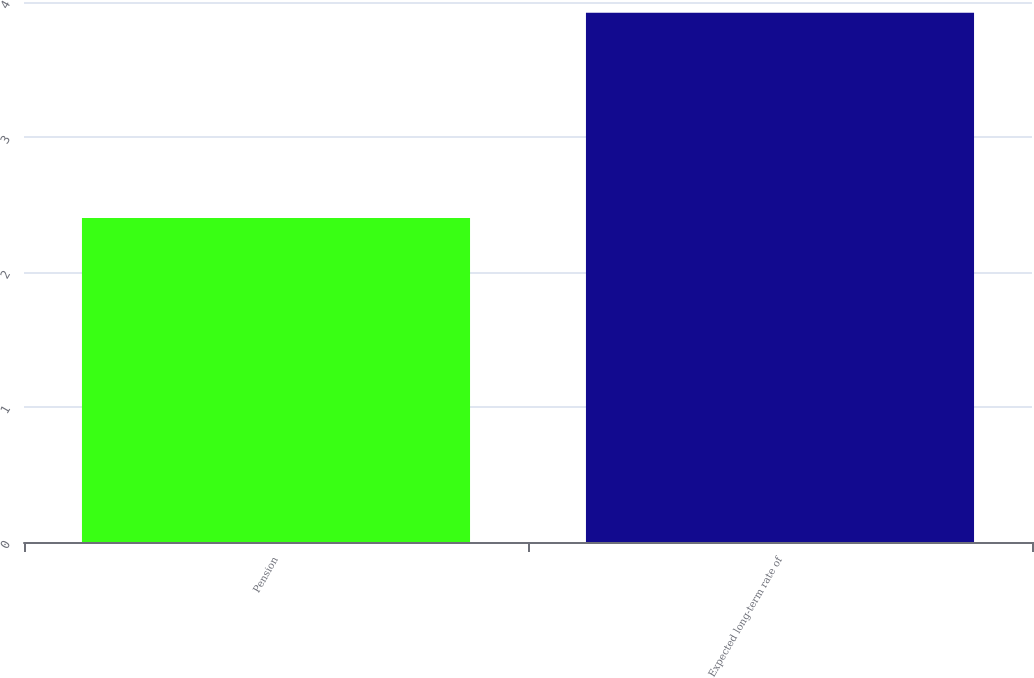Convert chart to OTSL. <chart><loc_0><loc_0><loc_500><loc_500><bar_chart><fcel>Pension<fcel>Expected long-term rate of<nl><fcel>2.4<fcel>3.92<nl></chart> 